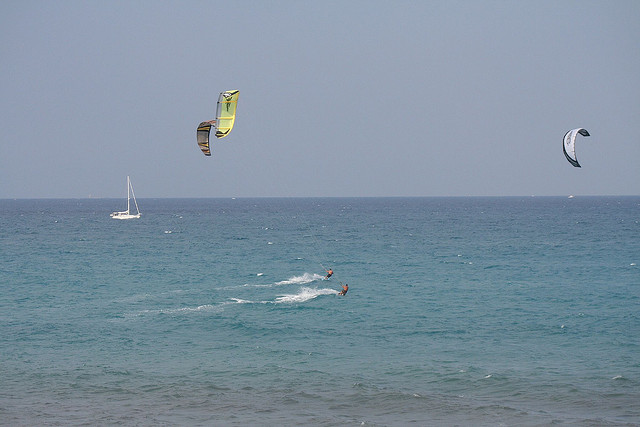If you were to describe the excitement level of the people in the image, how would you do it? The excitement level of the individuals partaking in kite surfing in the image is likely very high. They are fully engaged, gliding over the water and maneuvering their kites to achieve thrilling speeds and heights. The combination of the dynamic sport and the beautiful ocean setting enhances the overall exhilaration. 